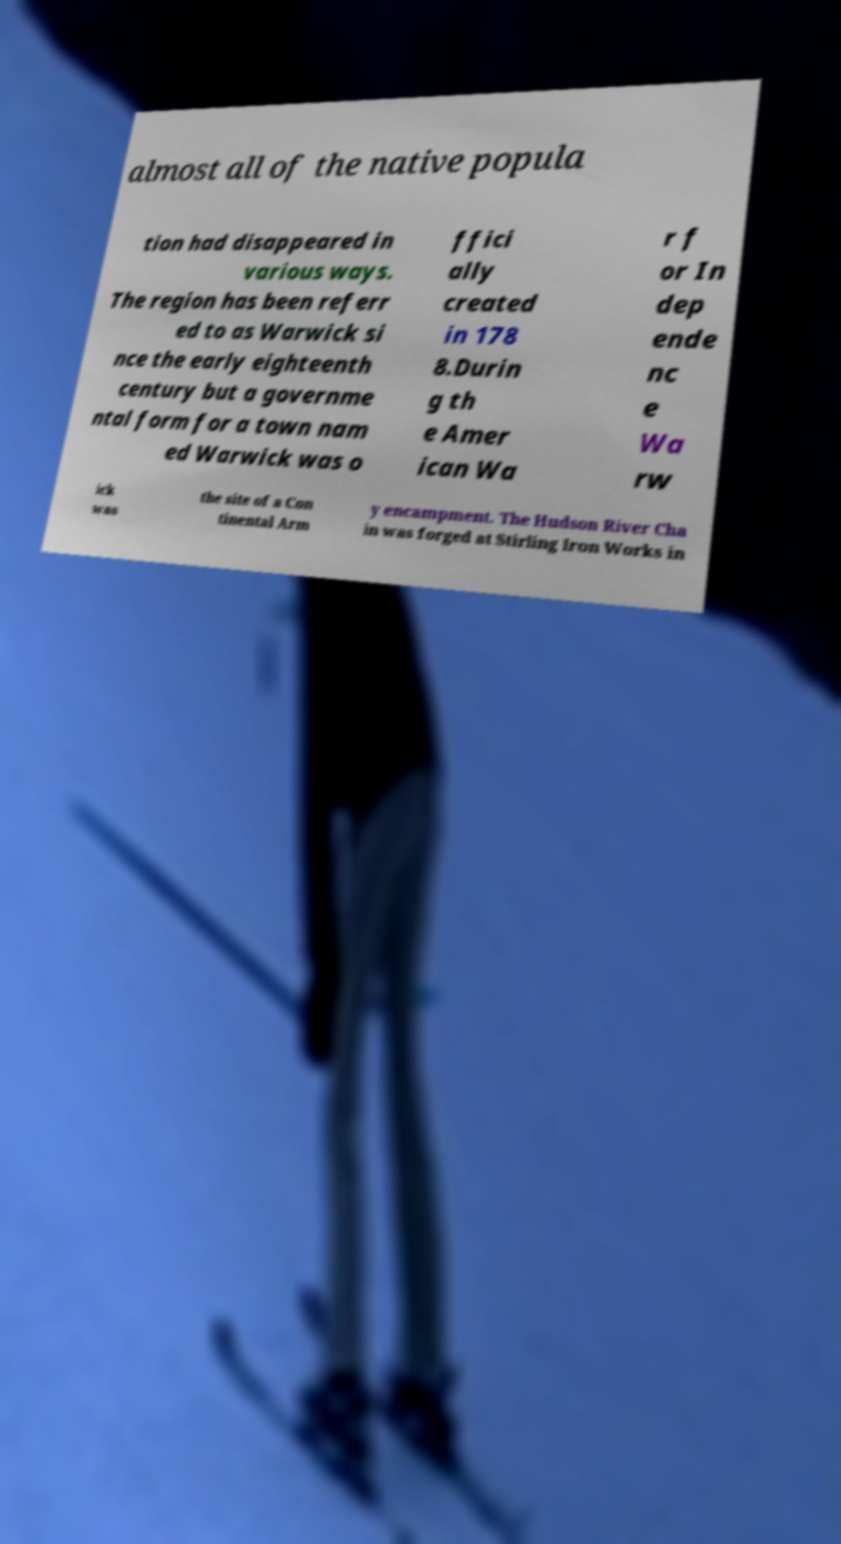Can you read and provide the text displayed in the image?This photo seems to have some interesting text. Can you extract and type it out for me? almost all of the native popula tion had disappeared in various ways. The region has been referr ed to as Warwick si nce the early eighteenth century but a governme ntal form for a town nam ed Warwick was o ffici ally created in 178 8.Durin g th e Amer ican Wa r f or In dep ende nc e Wa rw ick was the site of a Con tinental Arm y encampment. The Hudson River Cha in was forged at Stirling Iron Works in 